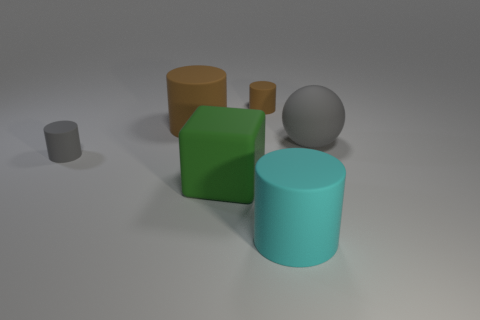Do the objects in the image look heavy or light? The perceived weight of the objects varies. The larger cylinders, due to their size and smooth texture, give the impression of being heavier, potentially made of metal or dense plastic. The smaller objects, such as the small cylinder and the cube, seem lighter, which could be made of a lighter plastic or wood. The sphere's texture implies solidity and weight, suggesting it might be a heavy ball, perhaps of stone or metal. 